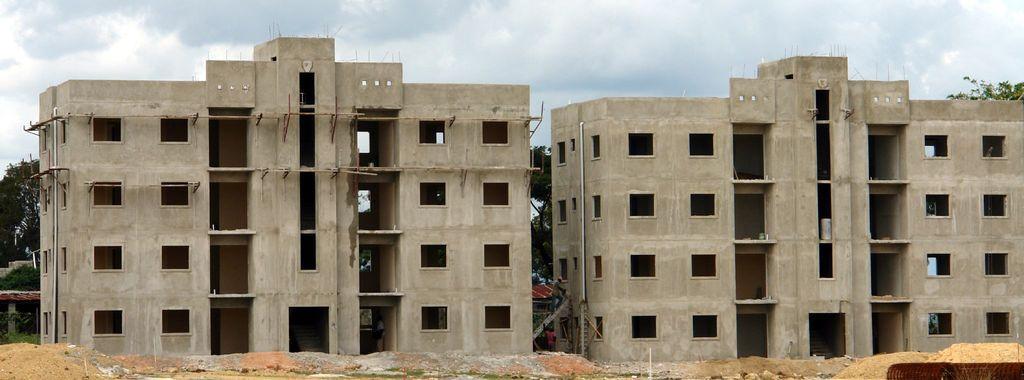Could you give a brief overview of what you see in this image? In the foreground of this image, there is a sand on the ground. In the middle, there are two buildings and we can also see few persons. In the background, there are trees, sky and the cloud. 